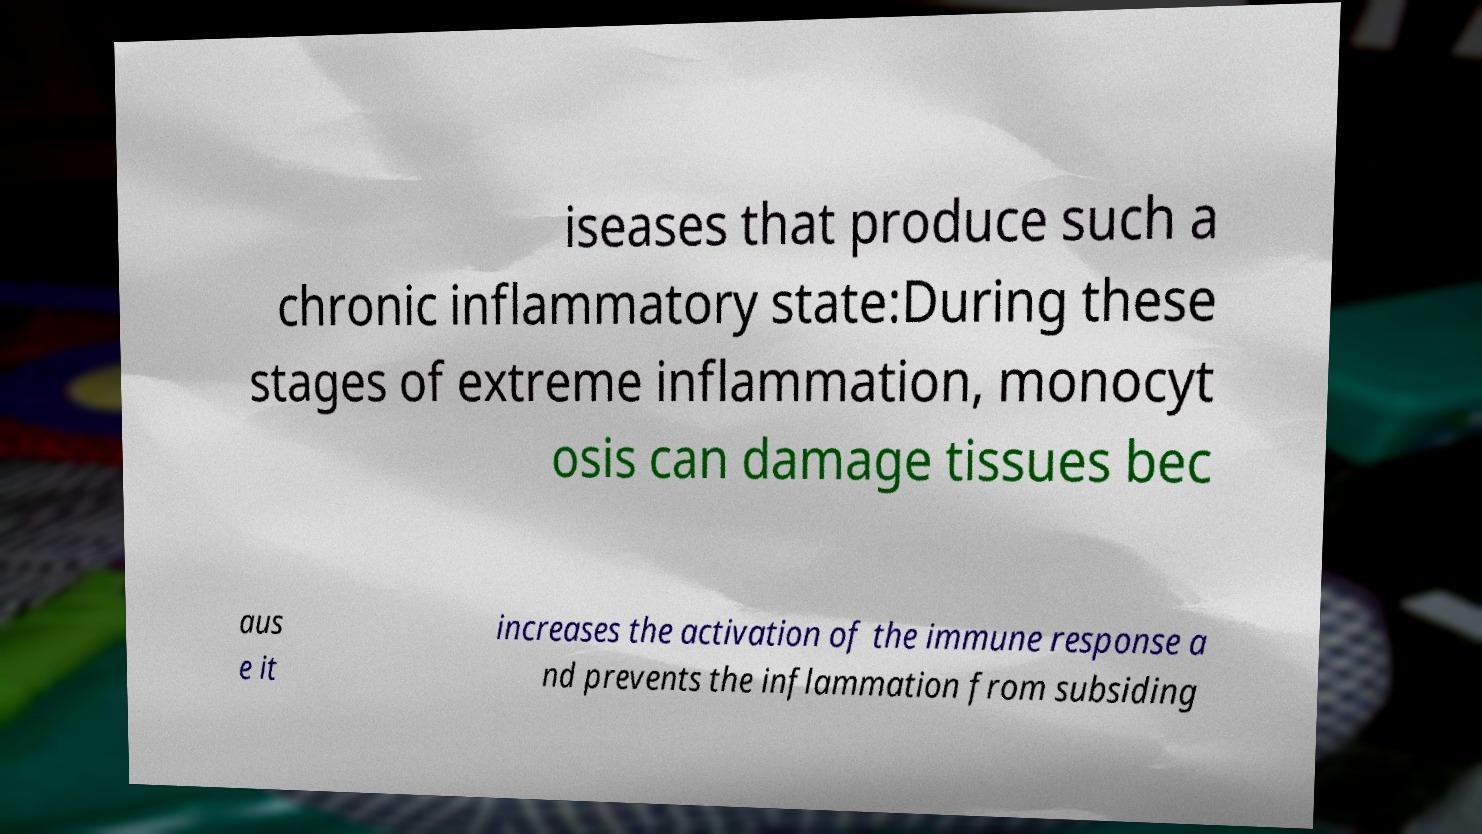Can you read and provide the text displayed in the image?This photo seems to have some interesting text. Can you extract and type it out for me? iseases that produce such a chronic inflammatory state:During these stages of extreme inflammation, monocyt osis can damage tissues bec aus e it increases the activation of the immune response a nd prevents the inflammation from subsiding 